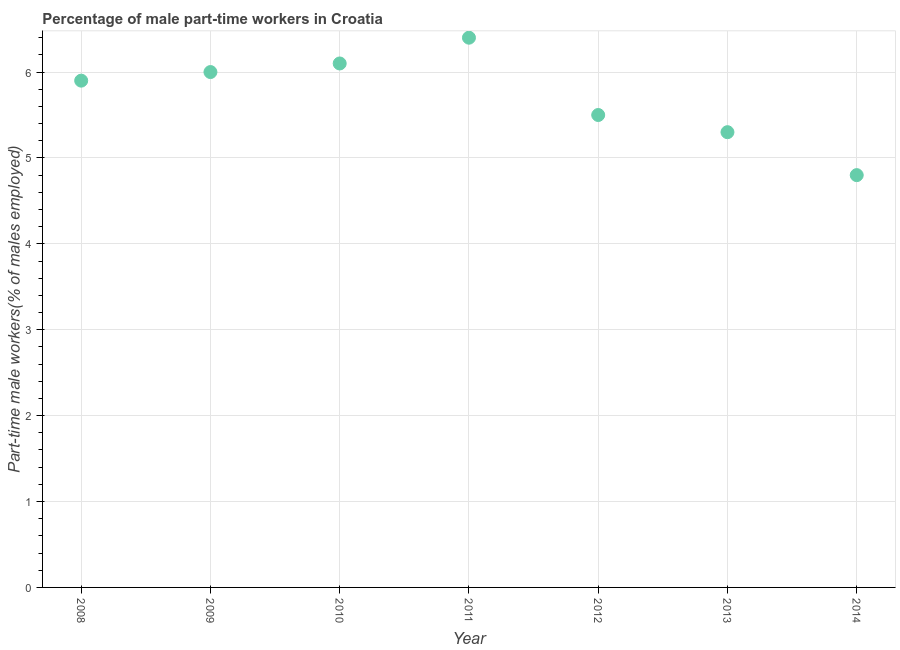What is the percentage of part-time male workers in 2014?
Ensure brevity in your answer.  4.8. Across all years, what is the maximum percentage of part-time male workers?
Give a very brief answer. 6.4. Across all years, what is the minimum percentage of part-time male workers?
Offer a very short reply. 4.8. In which year was the percentage of part-time male workers minimum?
Provide a succinct answer. 2014. What is the sum of the percentage of part-time male workers?
Make the answer very short. 40. What is the average percentage of part-time male workers per year?
Your answer should be very brief. 5.71. What is the median percentage of part-time male workers?
Give a very brief answer. 5.9. Do a majority of the years between 2011 and 2014 (inclusive) have percentage of part-time male workers greater than 5.4 %?
Make the answer very short. No. What is the ratio of the percentage of part-time male workers in 2008 to that in 2009?
Provide a short and direct response. 0.98. Is the difference between the percentage of part-time male workers in 2013 and 2014 greater than the difference between any two years?
Give a very brief answer. No. What is the difference between the highest and the second highest percentage of part-time male workers?
Offer a terse response. 0.3. Is the sum of the percentage of part-time male workers in 2010 and 2012 greater than the maximum percentage of part-time male workers across all years?
Your answer should be very brief. Yes. What is the difference between the highest and the lowest percentage of part-time male workers?
Offer a very short reply. 1.6. Does the percentage of part-time male workers monotonically increase over the years?
Give a very brief answer. No. Does the graph contain any zero values?
Provide a short and direct response. No. What is the title of the graph?
Offer a terse response. Percentage of male part-time workers in Croatia. What is the label or title of the Y-axis?
Offer a very short reply. Part-time male workers(% of males employed). What is the Part-time male workers(% of males employed) in 2008?
Keep it short and to the point. 5.9. What is the Part-time male workers(% of males employed) in 2010?
Your answer should be very brief. 6.1. What is the Part-time male workers(% of males employed) in 2011?
Ensure brevity in your answer.  6.4. What is the Part-time male workers(% of males employed) in 2012?
Give a very brief answer. 5.5. What is the Part-time male workers(% of males employed) in 2013?
Ensure brevity in your answer.  5.3. What is the Part-time male workers(% of males employed) in 2014?
Provide a short and direct response. 4.8. What is the difference between the Part-time male workers(% of males employed) in 2008 and 2010?
Provide a short and direct response. -0.2. What is the difference between the Part-time male workers(% of males employed) in 2008 and 2012?
Keep it short and to the point. 0.4. What is the difference between the Part-time male workers(% of males employed) in 2008 and 2014?
Ensure brevity in your answer.  1.1. What is the difference between the Part-time male workers(% of males employed) in 2009 and 2012?
Give a very brief answer. 0.5. What is the difference between the Part-time male workers(% of males employed) in 2010 and 2011?
Offer a very short reply. -0.3. What is the difference between the Part-time male workers(% of males employed) in 2010 and 2012?
Offer a terse response. 0.6. What is the difference between the Part-time male workers(% of males employed) in 2010 and 2014?
Your response must be concise. 1.3. What is the difference between the Part-time male workers(% of males employed) in 2012 and 2013?
Ensure brevity in your answer.  0.2. What is the difference between the Part-time male workers(% of males employed) in 2012 and 2014?
Give a very brief answer. 0.7. What is the ratio of the Part-time male workers(% of males employed) in 2008 to that in 2009?
Provide a succinct answer. 0.98. What is the ratio of the Part-time male workers(% of males employed) in 2008 to that in 2010?
Ensure brevity in your answer.  0.97. What is the ratio of the Part-time male workers(% of males employed) in 2008 to that in 2011?
Offer a terse response. 0.92. What is the ratio of the Part-time male workers(% of males employed) in 2008 to that in 2012?
Offer a terse response. 1.07. What is the ratio of the Part-time male workers(% of males employed) in 2008 to that in 2013?
Your answer should be compact. 1.11. What is the ratio of the Part-time male workers(% of males employed) in 2008 to that in 2014?
Provide a succinct answer. 1.23. What is the ratio of the Part-time male workers(% of males employed) in 2009 to that in 2010?
Ensure brevity in your answer.  0.98. What is the ratio of the Part-time male workers(% of males employed) in 2009 to that in 2011?
Ensure brevity in your answer.  0.94. What is the ratio of the Part-time male workers(% of males employed) in 2009 to that in 2012?
Ensure brevity in your answer.  1.09. What is the ratio of the Part-time male workers(% of males employed) in 2009 to that in 2013?
Keep it short and to the point. 1.13. What is the ratio of the Part-time male workers(% of males employed) in 2009 to that in 2014?
Give a very brief answer. 1.25. What is the ratio of the Part-time male workers(% of males employed) in 2010 to that in 2011?
Your answer should be compact. 0.95. What is the ratio of the Part-time male workers(% of males employed) in 2010 to that in 2012?
Keep it short and to the point. 1.11. What is the ratio of the Part-time male workers(% of males employed) in 2010 to that in 2013?
Give a very brief answer. 1.15. What is the ratio of the Part-time male workers(% of males employed) in 2010 to that in 2014?
Keep it short and to the point. 1.27. What is the ratio of the Part-time male workers(% of males employed) in 2011 to that in 2012?
Offer a very short reply. 1.16. What is the ratio of the Part-time male workers(% of males employed) in 2011 to that in 2013?
Keep it short and to the point. 1.21. What is the ratio of the Part-time male workers(% of males employed) in 2011 to that in 2014?
Offer a terse response. 1.33. What is the ratio of the Part-time male workers(% of males employed) in 2012 to that in 2013?
Your response must be concise. 1.04. What is the ratio of the Part-time male workers(% of males employed) in 2012 to that in 2014?
Give a very brief answer. 1.15. What is the ratio of the Part-time male workers(% of males employed) in 2013 to that in 2014?
Your answer should be very brief. 1.1. 